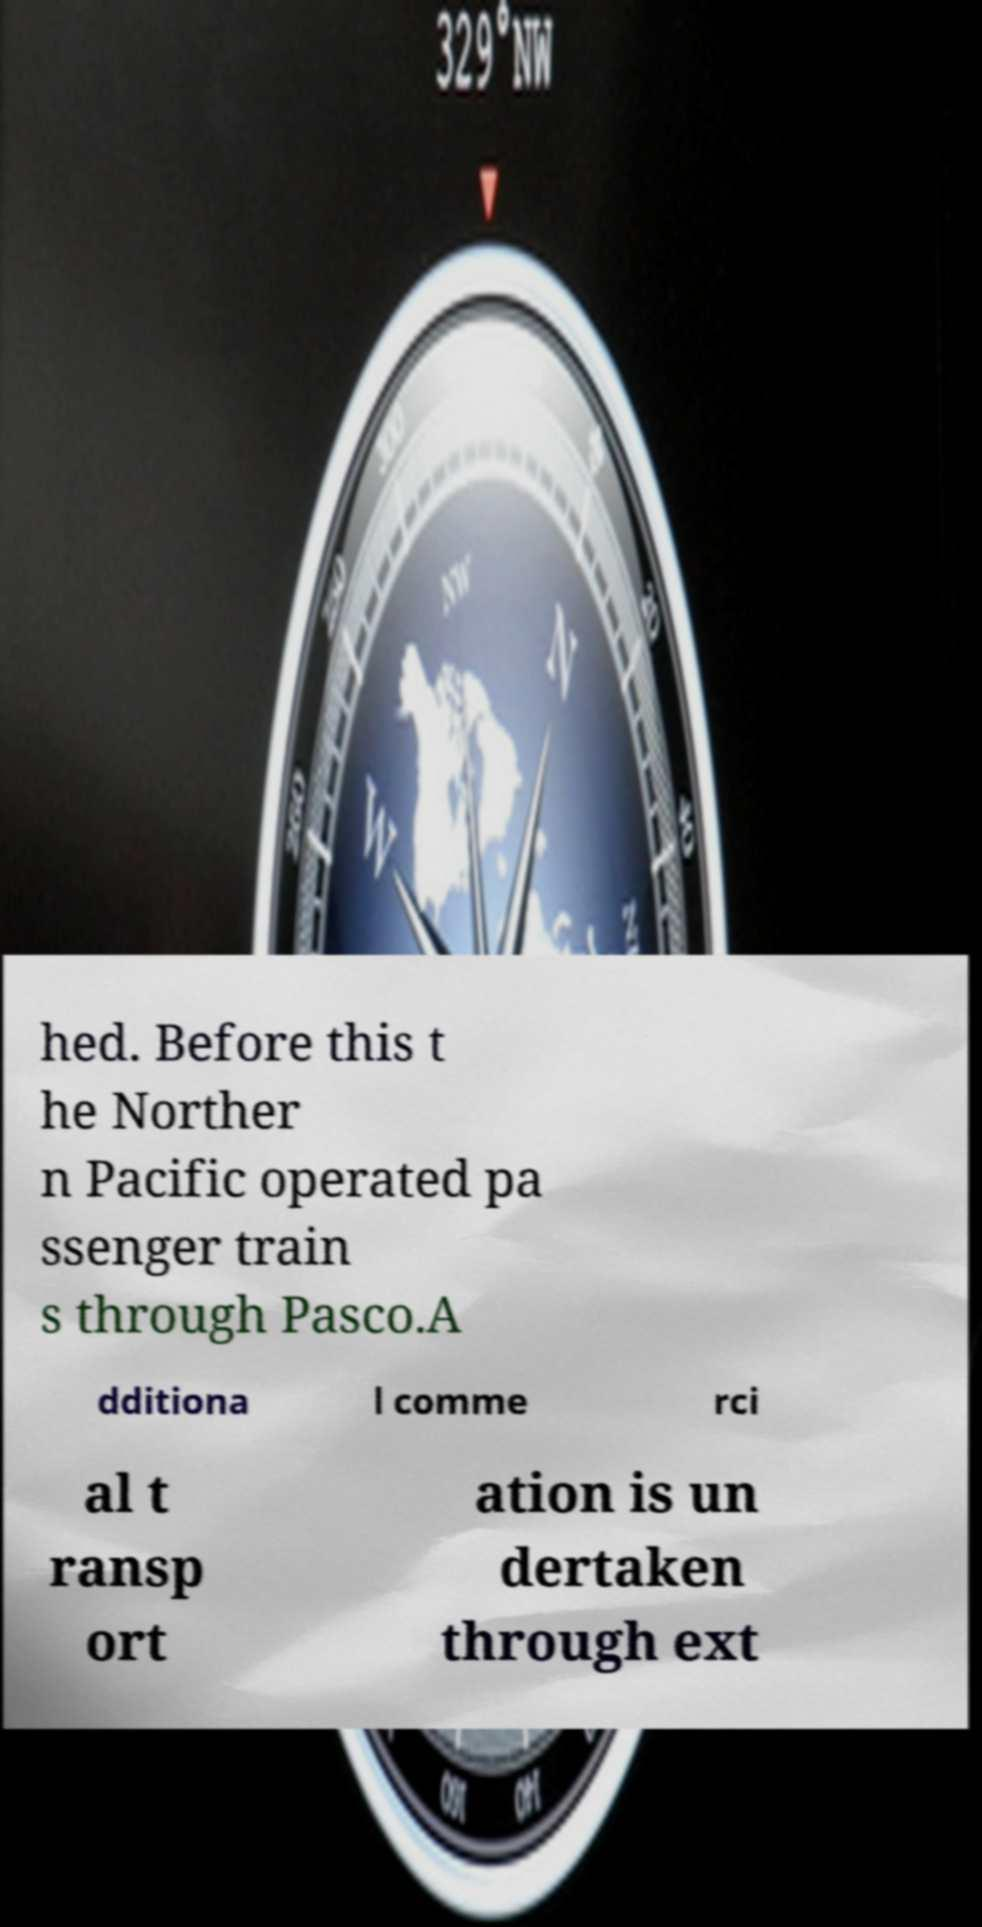What messages or text are displayed in this image? I need them in a readable, typed format. hed. Before this t he Norther n Pacific operated pa ssenger train s through Pasco.A dditiona l comme rci al t ransp ort ation is un dertaken through ext 